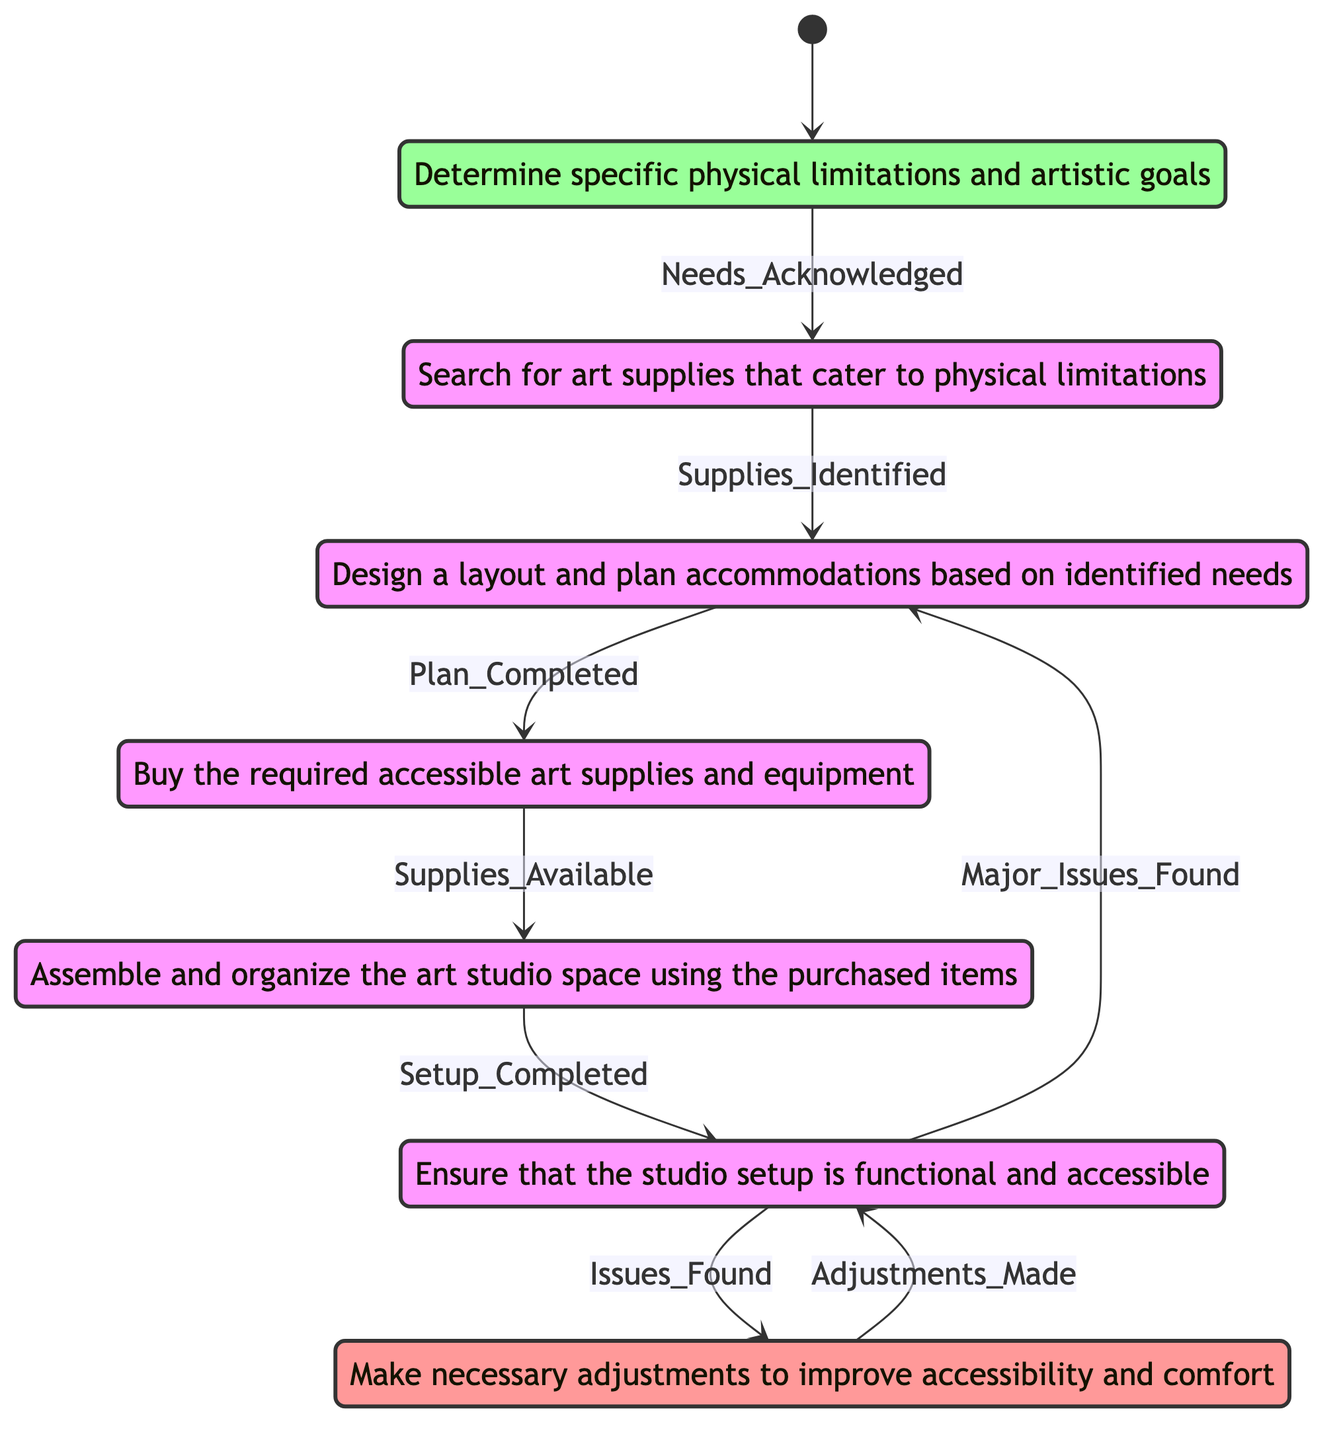What is the starting state of the diagram? The diagram begins with the state labeled "Identify_Needs", which indicates that the first step is to determine specific physical limitations and artistic goals.
Answer: Identify_Needs How many states are in the diagram? By counting the listed states in the diagram, including the start and end states, there are a total of seven states.
Answer: 7 What is the transition trigger from "Purchase_Supplies" to "Set_Up_Space"? The transition from "Purchase_Supplies" to "Set_Up_Space" is triggered when the supplies are available, as indicated by the transition label.
Answer: Supplies_Available What happens if issues are found during "Test_Accessibility"? If issues are found during "Test_Accessibility", the next step is to transition to "Adjustments_and_Improvements" to address those issues, as the diagram shows.
Answer: Adjustments_and_Improvements What is the last state of the diagram? The last state, or end state, of the diagram is labeled "Adjustments_and_Improvements", which indicates the final steps of making adjustments to improve accessibility and comfort.
Answer: Adjustments_and_Improvements What two states can follow "Test_Accessibility"? After "Test_Accessibility", the diagram indicates two potential states that can follow: "Adjustments_and_Improvements" if issues are found, or "Create_Accessibility_Plan" if major issues are found.
Answer: Adjustments_and_Improvements and Create_Accessibility_Plan How does one transition from "Create_Accessibility_Plan" to "Purchase_Supplies"? Transitioning from "Create_Accessibility_Plan" to "Purchase_Supplies" occurs when the plan is completed, as denoted by the specific trigger on the arrow between these states.
Answer: Plan_Completed Which state comes before "Research_Accessible_Supplies"? The state that comes before "Research_Accessible_Supplies" is "Identify_Needs", which indicates that needs must first be acknowledged before researching accessible supplies.
Answer: Identify_Needs 